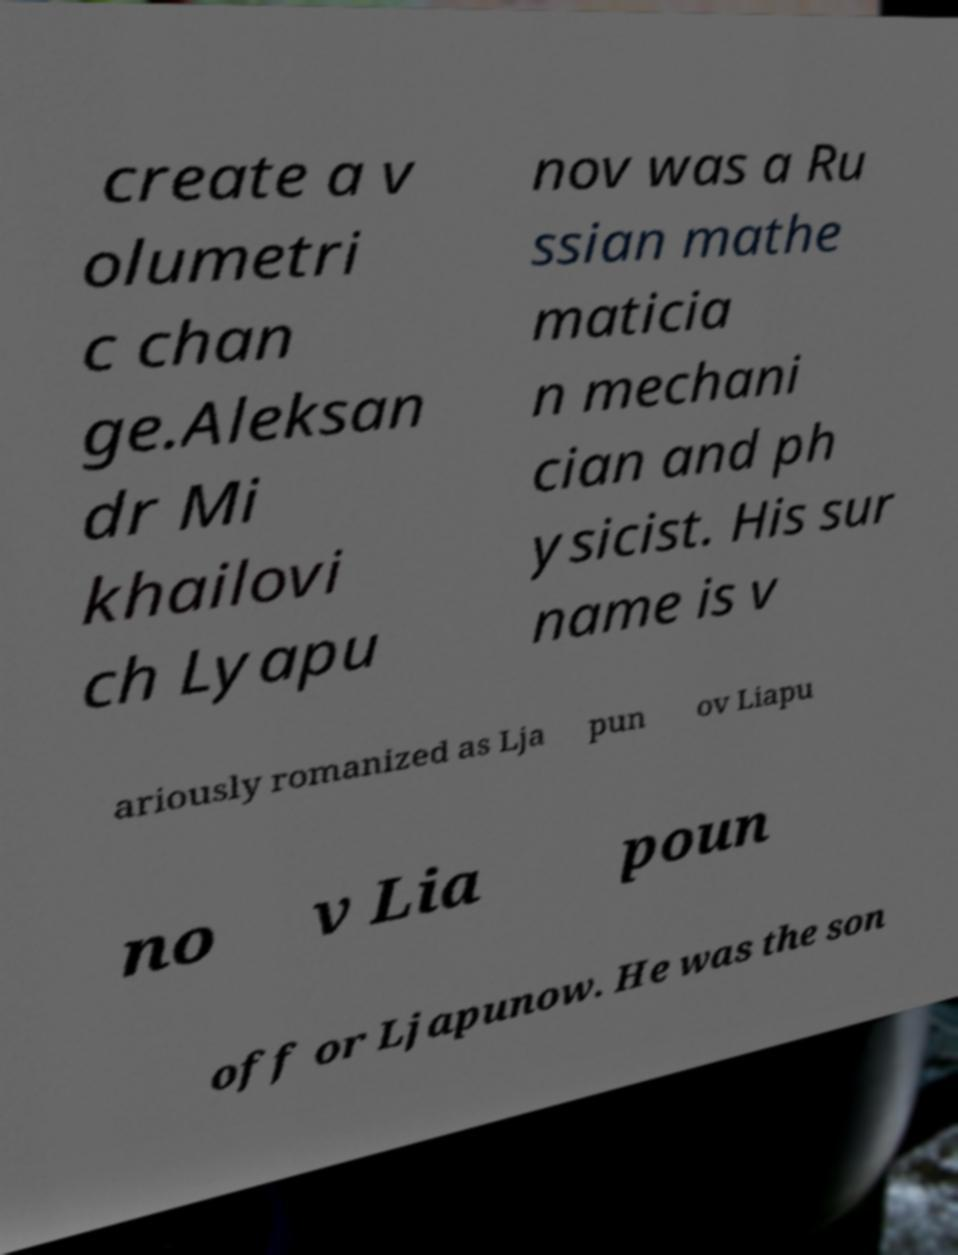There's text embedded in this image that I need extracted. Can you transcribe it verbatim? create a v olumetri c chan ge.Aleksan dr Mi khailovi ch Lyapu nov was a Ru ssian mathe maticia n mechani cian and ph ysicist. His sur name is v ariously romanized as Lja pun ov Liapu no v Lia poun off or Ljapunow. He was the son 